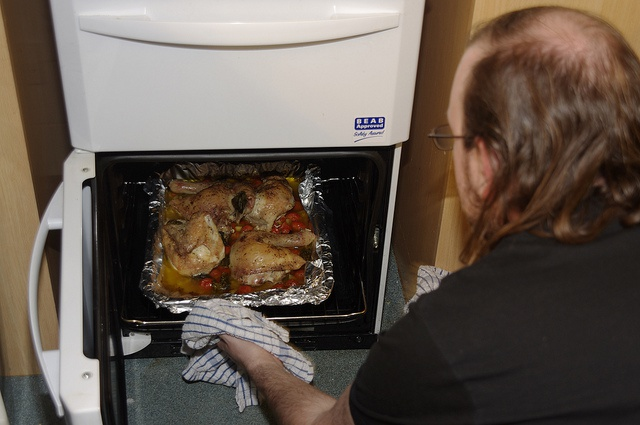Describe the objects in this image and their specific colors. I can see oven in maroon, black, lightgray, and darkgray tones and people in maroon, black, and gray tones in this image. 